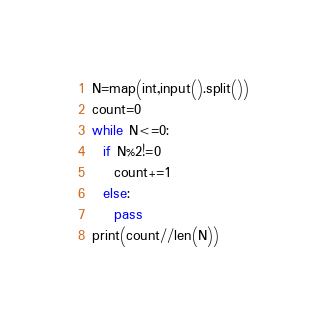Convert code to text. <code><loc_0><loc_0><loc_500><loc_500><_Python_>N=map(int,input().split())
count=0
while N<=0:
  if N%2!=0
  	count+=1
  else:
    pass
print(count//len(N))</code> 